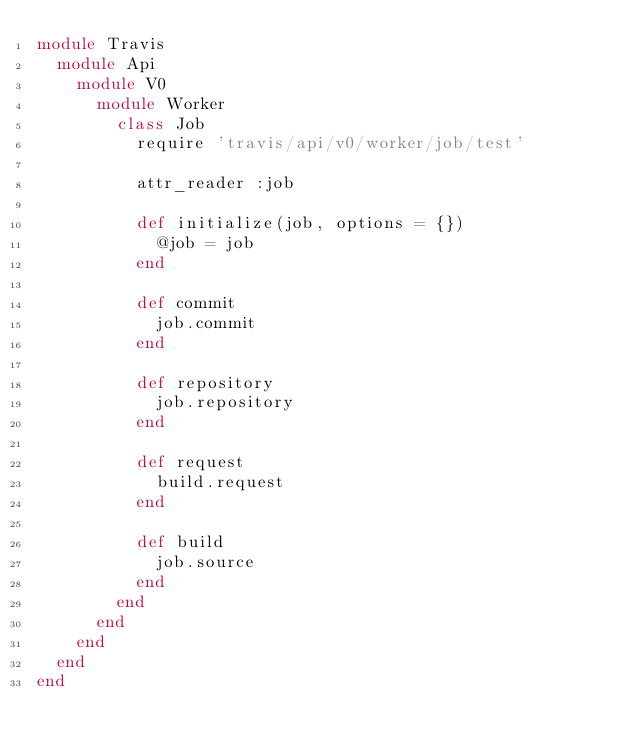Convert code to text. <code><loc_0><loc_0><loc_500><loc_500><_Ruby_>module Travis
  module Api
    module V0
      module Worker
        class Job
          require 'travis/api/v0/worker/job/test'

          attr_reader :job

          def initialize(job, options = {})
            @job = job
          end

          def commit
            job.commit
          end

          def repository
            job.repository
          end

          def request
            build.request
          end

          def build
            job.source
          end
        end
      end
    end
  end
end
</code> 